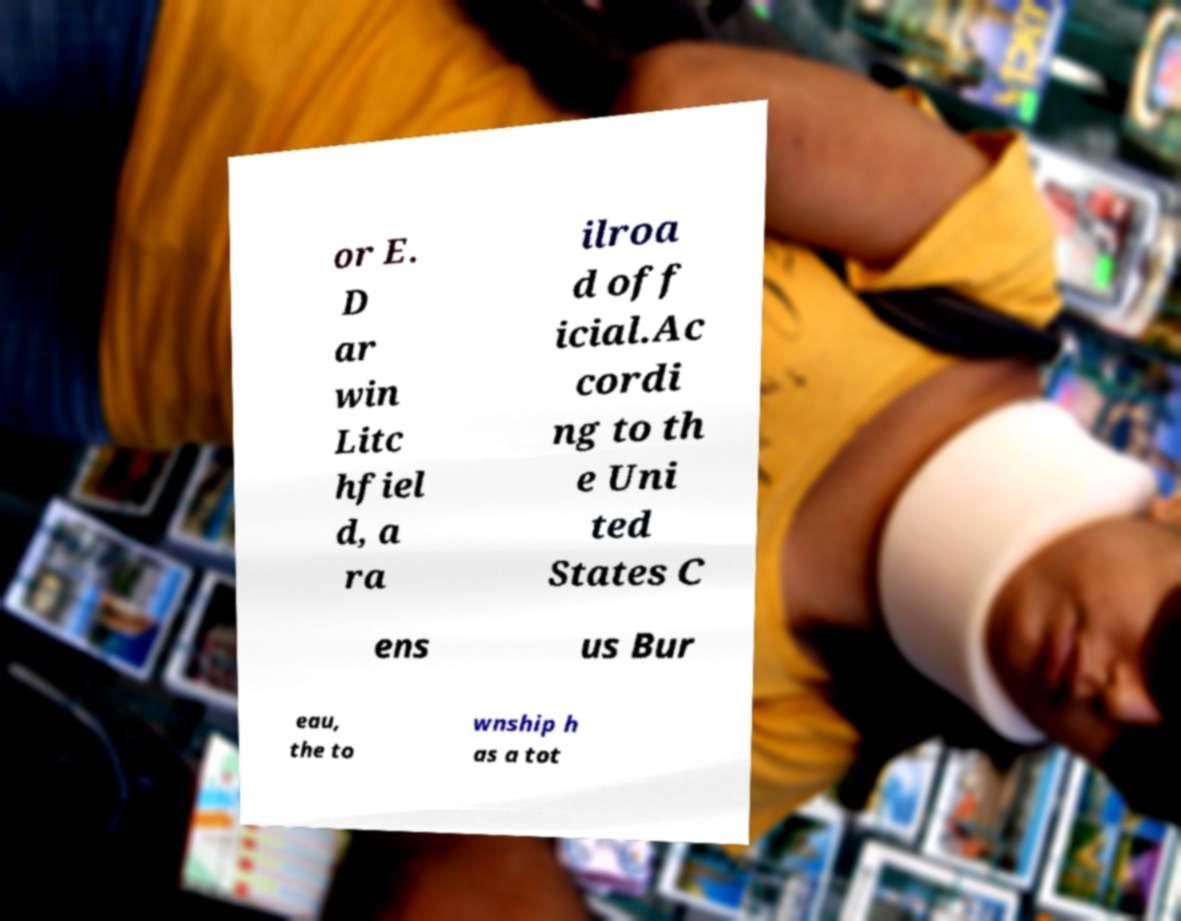I need the written content from this picture converted into text. Can you do that? or E. D ar win Litc hfiel d, a ra ilroa d off icial.Ac cordi ng to th e Uni ted States C ens us Bur eau, the to wnship h as a tot 